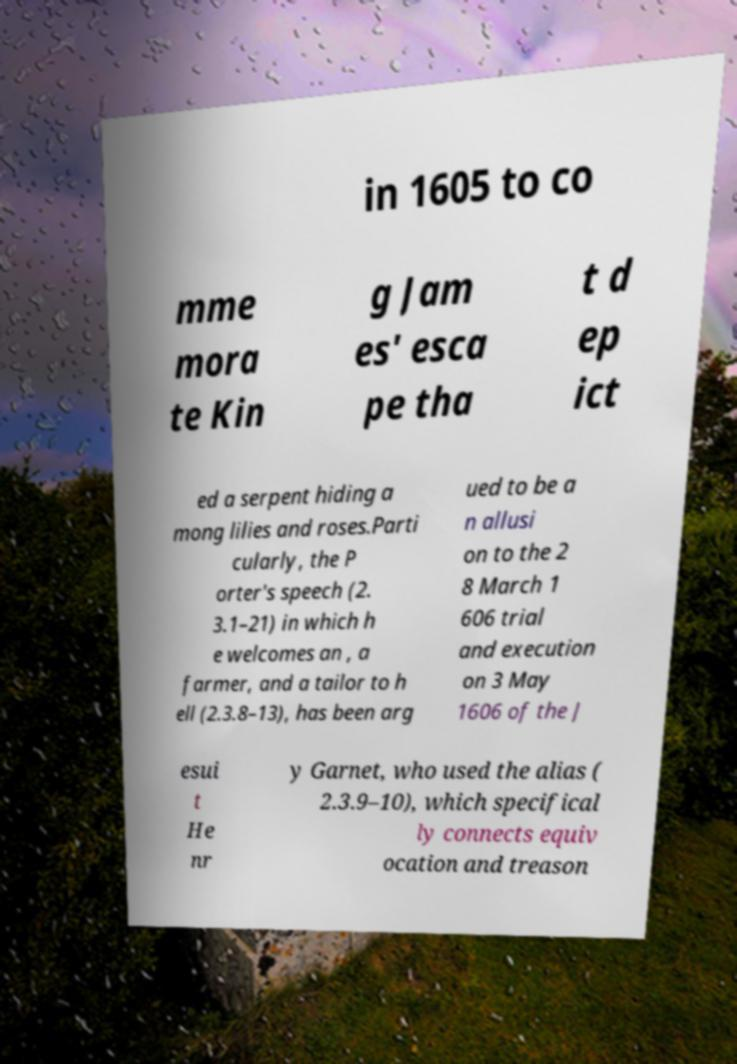Could you extract and type out the text from this image? in 1605 to co mme mora te Kin g Jam es' esca pe tha t d ep ict ed a serpent hiding a mong lilies and roses.Parti cularly, the P orter's speech (2. 3.1–21) in which h e welcomes an , a farmer, and a tailor to h ell (2.3.8–13), has been arg ued to be a n allusi on to the 2 8 March 1 606 trial and execution on 3 May 1606 of the J esui t He nr y Garnet, who used the alias ( 2.3.9–10), which specifical ly connects equiv ocation and treason 